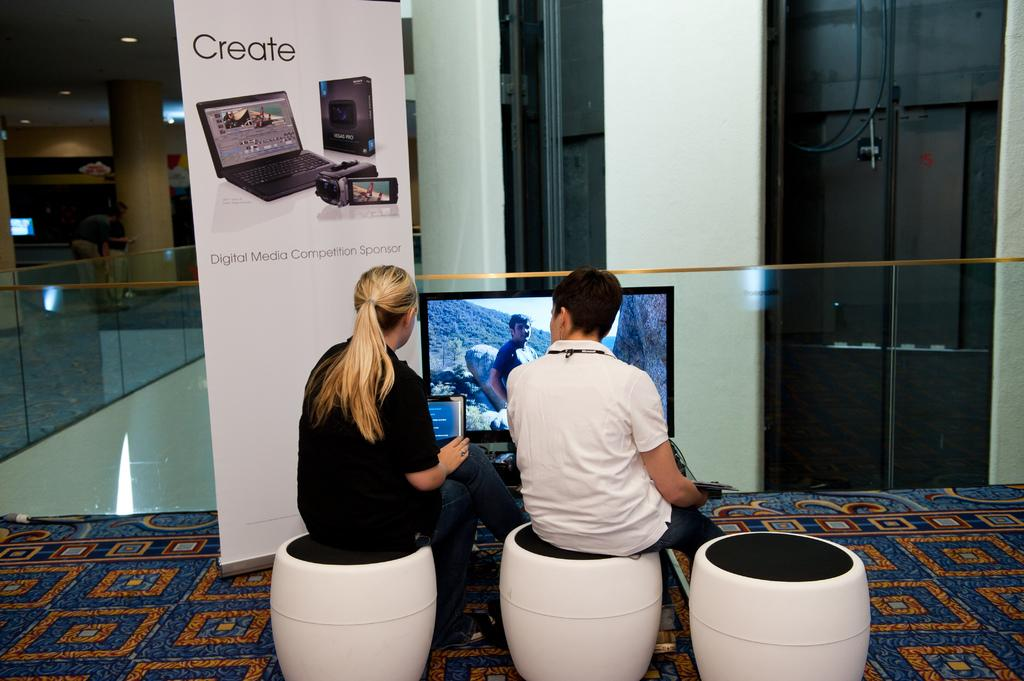<image>
Relay a brief, clear account of the picture shown. 2 people sitting on white chairs are near a display that says create. 